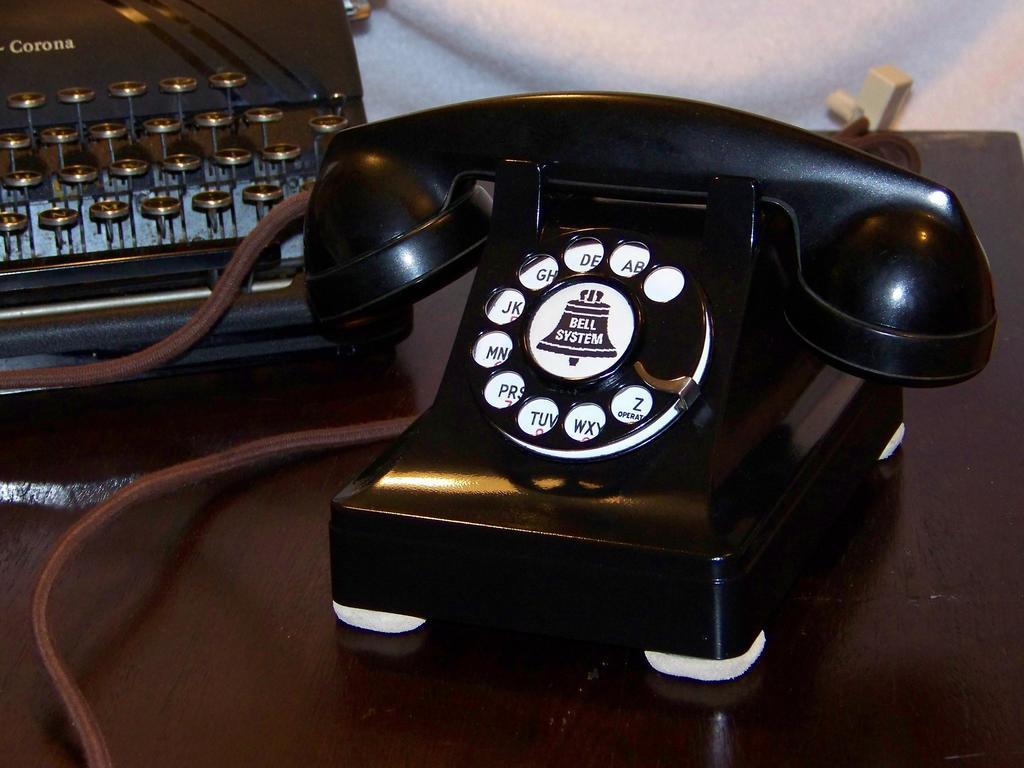Could you give a brief overview of what you see in this image? In this image we can see telephone placed on the table with a brown wire attached to it. In the background ,we can see a typewriter and a cloth. 